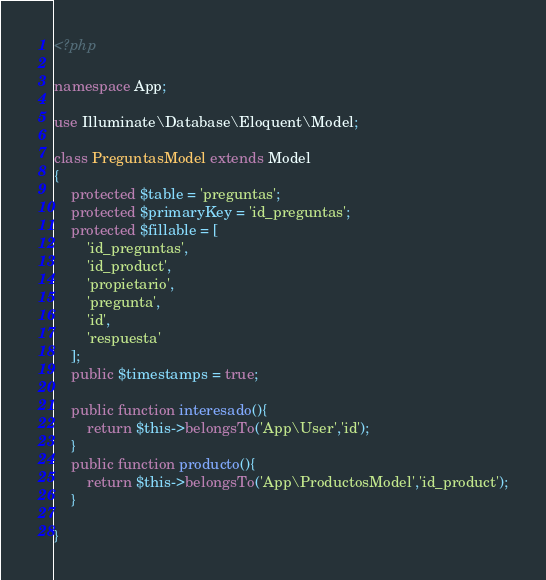<code> <loc_0><loc_0><loc_500><loc_500><_PHP_><?php

namespace App;

use Illuminate\Database\Eloquent\Model;

class PreguntasModel extends Model
{
    protected $table = 'preguntas';
    protected $primaryKey = 'id_preguntas';
    protected $fillable = [
        'id_preguntas',
        'id_product',
        'propietario',
        'pregunta',
        'id',
        'respuesta'
    ];
    public $timestamps = true;

    public function interesado(){
        return $this->belongsTo('App\User','id');
    }
    public function producto(){
        return $this->belongsTo('App\ProductosModel','id_product');
    }

}
</code> 